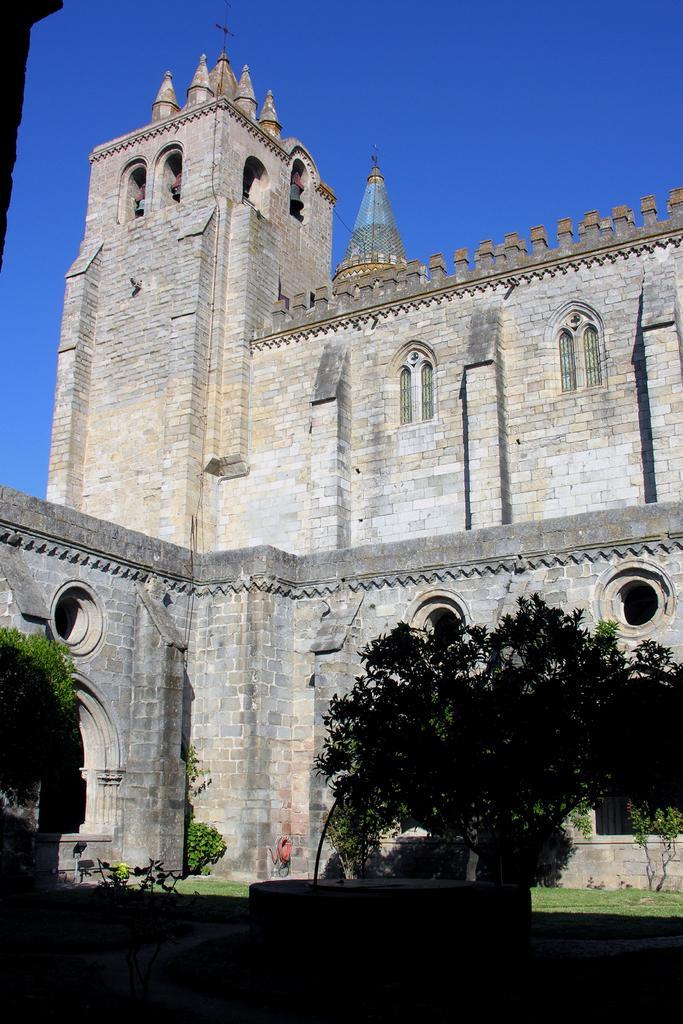In one or two sentences, can you explain what this image depicts? In this image we can see there is a tree and back side there is an old house and background is the sky. 